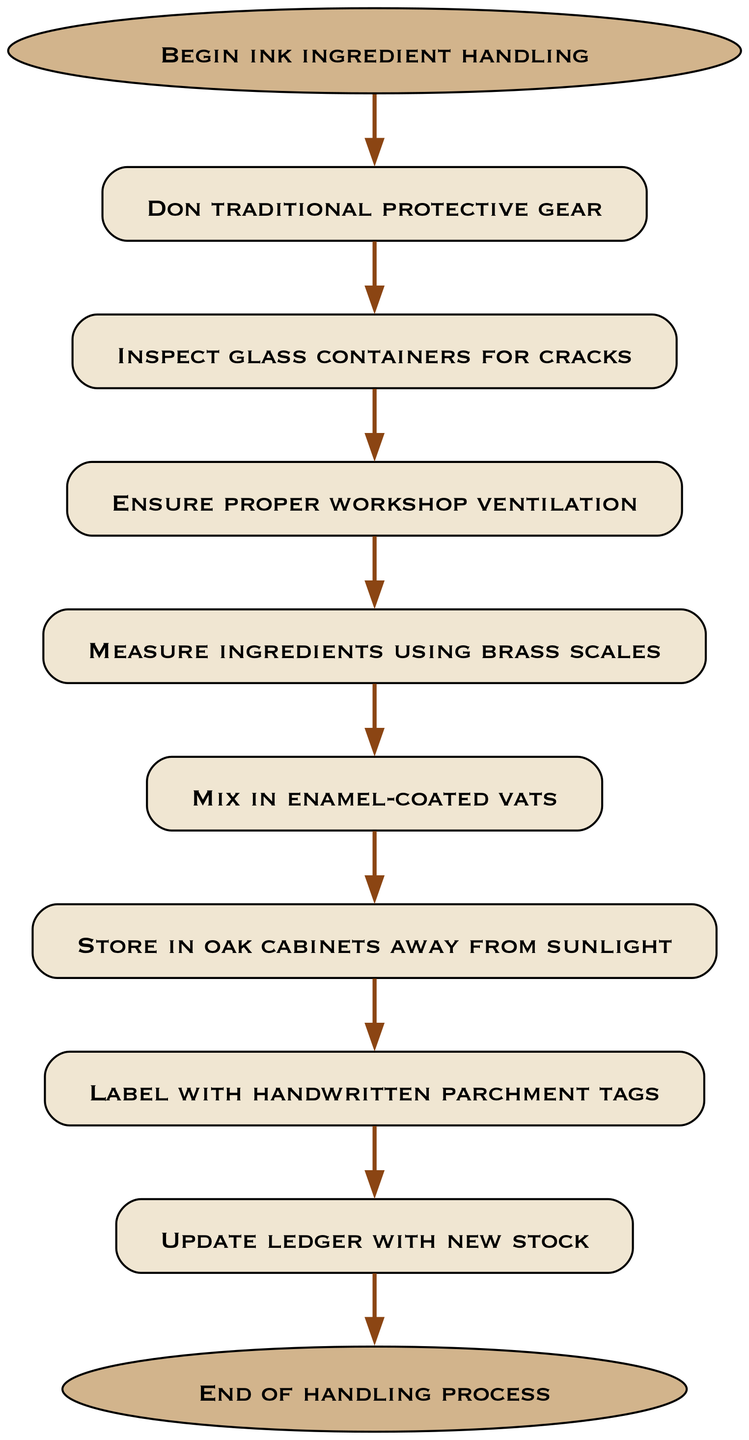What is the first action in the handling process? The first action in the flow chart is "Begin ink ingredient handling," which is represented by the starting node connected to the "Don traditional protective gear" node.
Answer: Begin ink ingredient handling How many steps are there in the handling process? By counting each node from start to end, we identify eight distinct actions or steps before concluding with the end node.
Answer: Eight What gear should be worn before handling ink ingredients? The diagram specifies that one should "Don traditional protective gear" as a necessary action immediately after starting the handling process.
Answer: Traditional protective gear What is the last action performed in the process? The flow chart culminates with the action "End of handling process," which is the final node following the "Update ledger with new stock" step.
Answer: End of handling process Which step comes directly after ensuring proper workshop ventilation? According to the diagram, after the step "Ensure proper workshop ventilation," the next action to be taken is "Measure ingredients using brass scales."
Answer: Measure ingredients using brass scales What should be used to label the stored ink? The diagram indicates that ink should be labeled with "handwritten parchment tags," which is the step that comes after storing the ink.
Answer: Handwritten parchment tags What is the connection type between the "Mix in enamel-coated vats" and "Store in oak cabinets away from sunlight"? The flow chart shows a direct connection indicating a sequence of actions, meaning "Mix in enamel-coated vats" must be completed before proceeding to "Store in oak cabinets away from sunlight."
Answer: Direct connection What action follows the inspection of glass containers? Following the "Inspect glass containers for cracks," the next required action is to "Ensure proper workshop ventilation."
Answer: Ensure proper workshop ventilation 